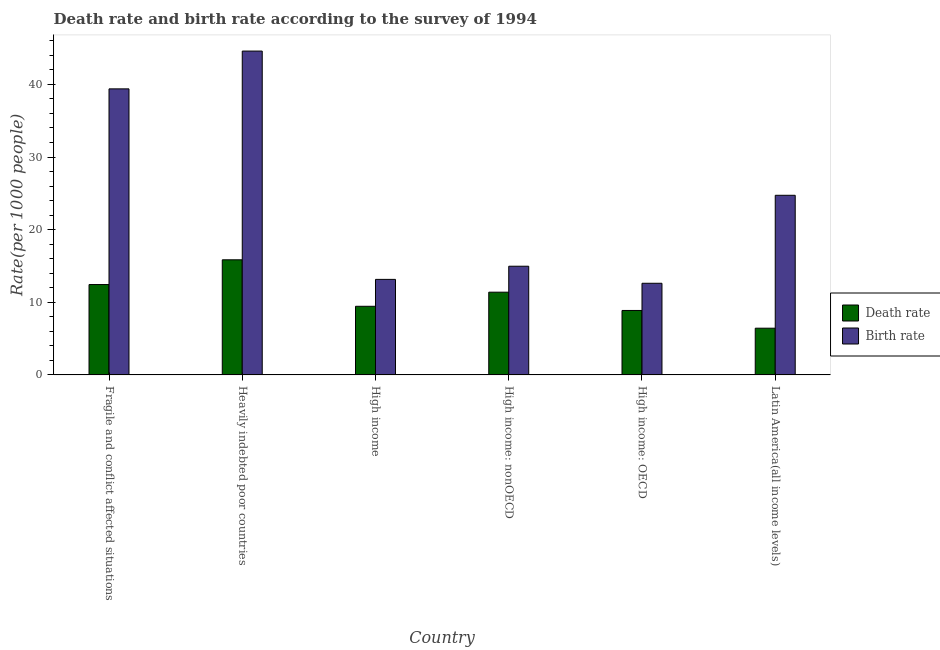How many groups of bars are there?
Offer a very short reply. 6. Are the number of bars per tick equal to the number of legend labels?
Make the answer very short. Yes. How many bars are there on the 6th tick from the right?
Offer a terse response. 2. What is the label of the 2nd group of bars from the left?
Your answer should be very brief. Heavily indebted poor countries. What is the birth rate in Latin America(all income levels)?
Provide a succinct answer. 24.73. Across all countries, what is the maximum death rate?
Offer a terse response. 15.85. Across all countries, what is the minimum birth rate?
Your response must be concise. 12.62. In which country was the birth rate maximum?
Your answer should be compact. Heavily indebted poor countries. In which country was the birth rate minimum?
Offer a very short reply. High income: OECD. What is the total birth rate in the graph?
Provide a short and direct response. 149.43. What is the difference between the birth rate in High income and that in High income: nonOECD?
Keep it short and to the point. -1.81. What is the difference between the death rate in High income: OECD and the birth rate in High income?
Make the answer very short. -4.28. What is the average birth rate per country?
Your answer should be very brief. 24.91. What is the difference between the death rate and birth rate in Fragile and conflict affected situations?
Give a very brief answer. -26.94. In how many countries, is the death rate greater than 8 ?
Provide a succinct answer. 5. What is the ratio of the birth rate in High income to that in High income: OECD?
Offer a terse response. 1.04. Is the birth rate in Heavily indebted poor countries less than that in Latin America(all income levels)?
Keep it short and to the point. No. Is the difference between the death rate in Heavily indebted poor countries and Latin America(all income levels) greater than the difference between the birth rate in Heavily indebted poor countries and Latin America(all income levels)?
Offer a terse response. No. What is the difference between the highest and the second highest death rate?
Keep it short and to the point. 3.4. What is the difference between the highest and the lowest birth rate?
Your response must be concise. 31.97. In how many countries, is the death rate greater than the average death rate taken over all countries?
Keep it short and to the point. 3. Is the sum of the birth rate in High income and Latin America(all income levels) greater than the maximum death rate across all countries?
Make the answer very short. Yes. What does the 2nd bar from the left in High income: OECD represents?
Keep it short and to the point. Birth rate. What does the 2nd bar from the right in Heavily indebted poor countries represents?
Make the answer very short. Death rate. How many bars are there?
Provide a succinct answer. 12. How many countries are there in the graph?
Ensure brevity in your answer.  6. What is the difference between two consecutive major ticks on the Y-axis?
Make the answer very short. 10. Does the graph contain any zero values?
Offer a very short reply. No. Where does the legend appear in the graph?
Give a very brief answer. Center right. How many legend labels are there?
Offer a very short reply. 2. How are the legend labels stacked?
Your response must be concise. Vertical. What is the title of the graph?
Keep it short and to the point. Death rate and birth rate according to the survey of 1994. Does "Female" appear as one of the legend labels in the graph?
Ensure brevity in your answer.  No. What is the label or title of the X-axis?
Ensure brevity in your answer.  Country. What is the label or title of the Y-axis?
Your response must be concise. Rate(per 1000 people). What is the Rate(per 1000 people) in Death rate in Fragile and conflict affected situations?
Your answer should be compact. 12.44. What is the Rate(per 1000 people) in Birth rate in Fragile and conflict affected situations?
Provide a succinct answer. 39.38. What is the Rate(per 1000 people) of Death rate in Heavily indebted poor countries?
Make the answer very short. 15.85. What is the Rate(per 1000 people) in Birth rate in Heavily indebted poor countries?
Give a very brief answer. 44.59. What is the Rate(per 1000 people) of Death rate in High income?
Give a very brief answer. 9.45. What is the Rate(per 1000 people) of Birth rate in High income?
Ensure brevity in your answer.  13.15. What is the Rate(per 1000 people) of Death rate in High income: nonOECD?
Ensure brevity in your answer.  11.39. What is the Rate(per 1000 people) in Birth rate in High income: nonOECD?
Your answer should be compact. 14.96. What is the Rate(per 1000 people) in Death rate in High income: OECD?
Give a very brief answer. 8.87. What is the Rate(per 1000 people) in Birth rate in High income: OECD?
Give a very brief answer. 12.62. What is the Rate(per 1000 people) of Death rate in Latin America(all income levels)?
Your response must be concise. 6.43. What is the Rate(per 1000 people) of Birth rate in Latin America(all income levels)?
Your answer should be very brief. 24.73. Across all countries, what is the maximum Rate(per 1000 people) in Death rate?
Your answer should be compact. 15.85. Across all countries, what is the maximum Rate(per 1000 people) in Birth rate?
Offer a very short reply. 44.59. Across all countries, what is the minimum Rate(per 1000 people) in Death rate?
Ensure brevity in your answer.  6.43. Across all countries, what is the minimum Rate(per 1000 people) in Birth rate?
Give a very brief answer. 12.62. What is the total Rate(per 1000 people) in Death rate in the graph?
Give a very brief answer. 64.44. What is the total Rate(per 1000 people) in Birth rate in the graph?
Make the answer very short. 149.43. What is the difference between the Rate(per 1000 people) in Death rate in Fragile and conflict affected situations and that in Heavily indebted poor countries?
Ensure brevity in your answer.  -3.4. What is the difference between the Rate(per 1000 people) in Birth rate in Fragile and conflict affected situations and that in Heavily indebted poor countries?
Offer a terse response. -5.2. What is the difference between the Rate(per 1000 people) in Death rate in Fragile and conflict affected situations and that in High income?
Offer a very short reply. 3. What is the difference between the Rate(per 1000 people) of Birth rate in Fragile and conflict affected situations and that in High income?
Your answer should be very brief. 26.23. What is the difference between the Rate(per 1000 people) in Death rate in Fragile and conflict affected situations and that in High income: nonOECD?
Give a very brief answer. 1.05. What is the difference between the Rate(per 1000 people) of Birth rate in Fragile and conflict affected situations and that in High income: nonOECD?
Your response must be concise. 24.42. What is the difference between the Rate(per 1000 people) of Death rate in Fragile and conflict affected situations and that in High income: OECD?
Your answer should be very brief. 3.57. What is the difference between the Rate(per 1000 people) in Birth rate in Fragile and conflict affected situations and that in High income: OECD?
Your response must be concise. 26.77. What is the difference between the Rate(per 1000 people) in Death rate in Fragile and conflict affected situations and that in Latin America(all income levels)?
Your response must be concise. 6.01. What is the difference between the Rate(per 1000 people) of Birth rate in Fragile and conflict affected situations and that in Latin America(all income levels)?
Keep it short and to the point. 14.65. What is the difference between the Rate(per 1000 people) in Death rate in Heavily indebted poor countries and that in High income?
Ensure brevity in your answer.  6.4. What is the difference between the Rate(per 1000 people) of Birth rate in Heavily indebted poor countries and that in High income?
Give a very brief answer. 31.44. What is the difference between the Rate(per 1000 people) in Death rate in Heavily indebted poor countries and that in High income: nonOECD?
Offer a terse response. 4.46. What is the difference between the Rate(per 1000 people) of Birth rate in Heavily indebted poor countries and that in High income: nonOECD?
Give a very brief answer. 29.62. What is the difference between the Rate(per 1000 people) of Death rate in Heavily indebted poor countries and that in High income: OECD?
Offer a very short reply. 6.97. What is the difference between the Rate(per 1000 people) in Birth rate in Heavily indebted poor countries and that in High income: OECD?
Keep it short and to the point. 31.97. What is the difference between the Rate(per 1000 people) in Death rate in Heavily indebted poor countries and that in Latin America(all income levels)?
Your answer should be compact. 9.42. What is the difference between the Rate(per 1000 people) of Birth rate in Heavily indebted poor countries and that in Latin America(all income levels)?
Provide a short and direct response. 19.86. What is the difference between the Rate(per 1000 people) in Death rate in High income and that in High income: nonOECD?
Provide a short and direct response. -1.94. What is the difference between the Rate(per 1000 people) in Birth rate in High income and that in High income: nonOECD?
Offer a terse response. -1.81. What is the difference between the Rate(per 1000 people) in Death rate in High income and that in High income: OECD?
Provide a succinct answer. 0.57. What is the difference between the Rate(per 1000 people) in Birth rate in High income and that in High income: OECD?
Give a very brief answer. 0.54. What is the difference between the Rate(per 1000 people) in Death rate in High income and that in Latin America(all income levels)?
Your answer should be compact. 3.02. What is the difference between the Rate(per 1000 people) of Birth rate in High income and that in Latin America(all income levels)?
Provide a succinct answer. -11.58. What is the difference between the Rate(per 1000 people) in Death rate in High income: nonOECD and that in High income: OECD?
Your answer should be very brief. 2.52. What is the difference between the Rate(per 1000 people) of Birth rate in High income: nonOECD and that in High income: OECD?
Offer a terse response. 2.35. What is the difference between the Rate(per 1000 people) in Death rate in High income: nonOECD and that in Latin America(all income levels)?
Make the answer very short. 4.96. What is the difference between the Rate(per 1000 people) of Birth rate in High income: nonOECD and that in Latin America(all income levels)?
Provide a succinct answer. -9.77. What is the difference between the Rate(per 1000 people) in Death rate in High income: OECD and that in Latin America(all income levels)?
Offer a very short reply. 2.44. What is the difference between the Rate(per 1000 people) in Birth rate in High income: OECD and that in Latin America(all income levels)?
Give a very brief answer. -12.11. What is the difference between the Rate(per 1000 people) in Death rate in Fragile and conflict affected situations and the Rate(per 1000 people) in Birth rate in Heavily indebted poor countries?
Give a very brief answer. -32.14. What is the difference between the Rate(per 1000 people) of Death rate in Fragile and conflict affected situations and the Rate(per 1000 people) of Birth rate in High income?
Your answer should be compact. -0.71. What is the difference between the Rate(per 1000 people) in Death rate in Fragile and conflict affected situations and the Rate(per 1000 people) in Birth rate in High income: nonOECD?
Keep it short and to the point. -2.52. What is the difference between the Rate(per 1000 people) of Death rate in Fragile and conflict affected situations and the Rate(per 1000 people) of Birth rate in High income: OECD?
Ensure brevity in your answer.  -0.17. What is the difference between the Rate(per 1000 people) of Death rate in Fragile and conflict affected situations and the Rate(per 1000 people) of Birth rate in Latin America(all income levels)?
Keep it short and to the point. -12.29. What is the difference between the Rate(per 1000 people) of Death rate in Heavily indebted poor countries and the Rate(per 1000 people) of Birth rate in High income?
Provide a short and direct response. 2.7. What is the difference between the Rate(per 1000 people) in Death rate in Heavily indebted poor countries and the Rate(per 1000 people) in Birth rate in High income: nonOECD?
Offer a very short reply. 0.88. What is the difference between the Rate(per 1000 people) in Death rate in Heavily indebted poor countries and the Rate(per 1000 people) in Birth rate in High income: OECD?
Keep it short and to the point. 3.23. What is the difference between the Rate(per 1000 people) of Death rate in Heavily indebted poor countries and the Rate(per 1000 people) of Birth rate in Latin America(all income levels)?
Give a very brief answer. -8.88. What is the difference between the Rate(per 1000 people) of Death rate in High income and the Rate(per 1000 people) of Birth rate in High income: nonOECD?
Give a very brief answer. -5.51. What is the difference between the Rate(per 1000 people) of Death rate in High income and the Rate(per 1000 people) of Birth rate in High income: OECD?
Offer a terse response. -3.17. What is the difference between the Rate(per 1000 people) in Death rate in High income and the Rate(per 1000 people) in Birth rate in Latin America(all income levels)?
Offer a very short reply. -15.28. What is the difference between the Rate(per 1000 people) in Death rate in High income: nonOECD and the Rate(per 1000 people) in Birth rate in High income: OECD?
Offer a terse response. -1.22. What is the difference between the Rate(per 1000 people) of Death rate in High income: nonOECD and the Rate(per 1000 people) of Birth rate in Latin America(all income levels)?
Offer a very short reply. -13.34. What is the difference between the Rate(per 1000 people) in Death rate in High income: OECD and the Rate(per 1000 people) in Birth rate in Latin America(all income levels)?
Provide a short and direct response. -15.86. What is the average Rate(per 1000 people) in Death rate per country?
Ensure brevity in your answer.  10.74. What is the average Rate(per 1000 people) in Birth rate per country?
Keep it short and to the point. 24.91. What is the difference between the Rate(per 1000 people) in Death rate and Rate(per 1000 people) in Birth rate in Fragile and conflict affected situations?
Keep it short and to the point. -26.94. What is the difference between the Rate(per 1000 people) of Death rate and Rate(per 1000 people) of Birth rate in Heavily indebted poor countries?
Your answer should be compact. -28.74. What is the difference between the Rate(per 1000 people) of Death rate and Rate(per 1000 people) of Birth rate in High income?
Provide a succinct answer. -3.7. What is the difference between the Rate(per 1000 people) in Death rate and Rate(per 1000 people) in Birth rate in High income: nonOECD?
Your response must be concise. -3.57. What is the difference between the Rate(per 1000 people) of Death rate and Rate(per 1000 people) of Birth rate in High income: OECD?
Give a very brief answer. -3.74. What is the difference between the Rate(per 1000 people) in Death rate and Rate(per 1000 people) in Birth rate in Latin America(all income levels)?
Give a very brief answer. -18.3. What is the ratio of the Rate(per 1000 people) of Death rate in Fragile and conflict affected situations to that in Heavily indebted poor countries?
Provide a succinct answer. 0.79. What is the ratio of the Rate(per 1000 people) of Birth rate in Fragile and conflict affected situations to that in Heavily indebted poor countries?
Your answer should be very brief. 0.88. What is the ratio of the Rate(per 1000 people) of Death rate in Fragile and conflict affected situations to that in High income?
Offer a terse response. 1.32. What is the ratio of the Rate(per 1000 people) of Birth rate in Fragile and conflict affected situations to that in High income?
Offer a very short reply. 2.99. What is the ratio of the Rate(per 1000 people) in Death rate in Fragile and conflict affected situations to that in High income: nonOECD?
Keep it short and to the point. 1.09. What is the ratio of the Rate(per 1000 people) of Birth rate in Fragile and conflict affected situations to that in High income: nonOECD?
Keep it short and to the point. 2.63. What is the ratio of the Rate(per 1000 people) in Death rate in Fragile and conflict affected situations to that in High income: OECD?
Your response must be concise. 1.4. What is the ratio of the Rate(per 1000 people) of Birth rate in Fragile and conflict affected situations to that in High income: OECD?
Give a very brief answer. 3.12. What is the ratio of the Rate(per 1000 people) of Death rate in Fragile and conflict affected situations to that in Latin America(all income levels)?
Give a very brief answer. 1.93. What is the ratio of the Rate(per 1000 people) of Birth rate in Fragile and conflict affected situations to that in Latin America(all income levels)?
Offer a terse response. 1.59. What is the ratio of the Rate(per 1000 people) of Death rate in Heavily indebted poor countries to that in High income?
Your answer should be very brief. 1.68. What is the ratio of the Rate(per 1000 people) of Birth rate in Heavily indebted poor countries to that in High income?
Give a very brief answer. 3.39. What is the ratio of the Rate(per 1000 people) in Death rate in Heavily indebted poor countries to that in High income: nonOECD?
Your answer should be compact. 1.39. What is the ratio of the Rate(per 1000 people) in Birth rate in Heavily indebted poor countries to that in High income: nonOECD?
Your answer should be very brief. 2.98. What is the ratio of the Rate(per 1000 people) in Death rate in Heavily indebted poor countries to that in High income: OECD?
Your answer should be compact. 1.79. What is the ratio of the Rate(per 1000 people) of Birth rate in Heavily indebted poor countries to that in High income: OECD?
Your response must be concise. 3.53. What is the ratio of the Rate(per 1000 people) in Death rate in Heavily indebted poor countries to that in Latin America(all income levels)?
Provide a succinct answer. 2.46. What is the ratio of the Rate(per 1000 people) of Birth rate in Heavily indebted poor countries to that in Latin America(all income levels)?
Offer a very short reply. 1.8. What is the ratio of the Rate(per 1000 people) of Death rate in High income to that in High income: nonOECD?
Provide a short and direct response. 0.83. What is the ratio of the Rate(per 1000 people) in Birth rate in High income to that in High income: nonOECD?
Provide a short and direct response. 0.88. What is the ratio of the Rate(per 1000 people) in Death rate in High income to that in High income: OECD?
Give a very brief answer. 1.06. What is the ratio of the Rate(per 1000 people) in Birth rate in High income to that in High income: OECD?
Ensure brevity in your answer.  1.04. What is the ratio of the Rate(per 1000 people) of Death rate in High income to that in Latin America(all income levels)?
Make the answer very short. 1.47. What is the ratio of the Rate(per 1000 people) of Birth rate in High income to that in Latin America(all income levels)?
Provide a succinct answer. 0.53. What is the ratio of the Rate(per 1000 people) of Death rate in High income: nonOECD to that in High income: OECD?
Your answer should be very brief. 1.28. What is the ratio of the Rate(per 1000 people) of Birth rate in High income: nonOECD to that in High income: OECD?
Provide a succinct answer. 1.19. What is the ratio of the Rate(per 1000 people) of Death rate in High income: nonOECD to that in Latin America(all income levels)?
Keep it short and to the point. 1.77. What is the ratio of the Rate(per 1000 people) of Birth rate in High income: nonOECD to that in Latin America(all income levels)?
Ensure brevity in your answer.  0.61. What is the ratio of the Rate(per 1000 people) of Death rate in High income: OECD to that in Latin America(all income levels)?
Provide a succinct answer. 1.38. What is the ratio of the Rate(per 1000 people) of Birth rate in High income: OECD to that in Latin America(all income levels)?
Make the answer very short. 0.51. What is the difference between the highest and the second highest Rate(per 1000 people) of Death rate?
Offer a very short reply. 3.4. What is the difference between the highest and the second highest Rate(per 1000 people) in Birth rate?
Make the answer very short. 5.2. What is the difference between the highest and the lowest Rate(per 1000 people) of Death rate?
Offer a very short reply. 9.42. What is the difference between the highest and the lowest Rate(per 1000 people) in Birth rate?
Your response must be concise. 31.97. 